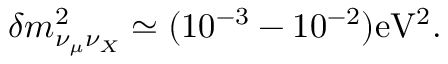Convert formula to latex. <formula><loc_0><loc_0><loc_500><loc_500>\delta m _ { \nu _ { \mu } \nu _ { X } } ^ { 2 } \simeq ( 1 0 ^ { - 3 } - 1 0 ^ { - 2 } ) e V ^ { 2 } .</formula> 